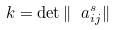<formula> <loc_0><loc_0><loc_500><loc_500>k = \det \| \ a ^ { s } _ { i j } \|</formula> 